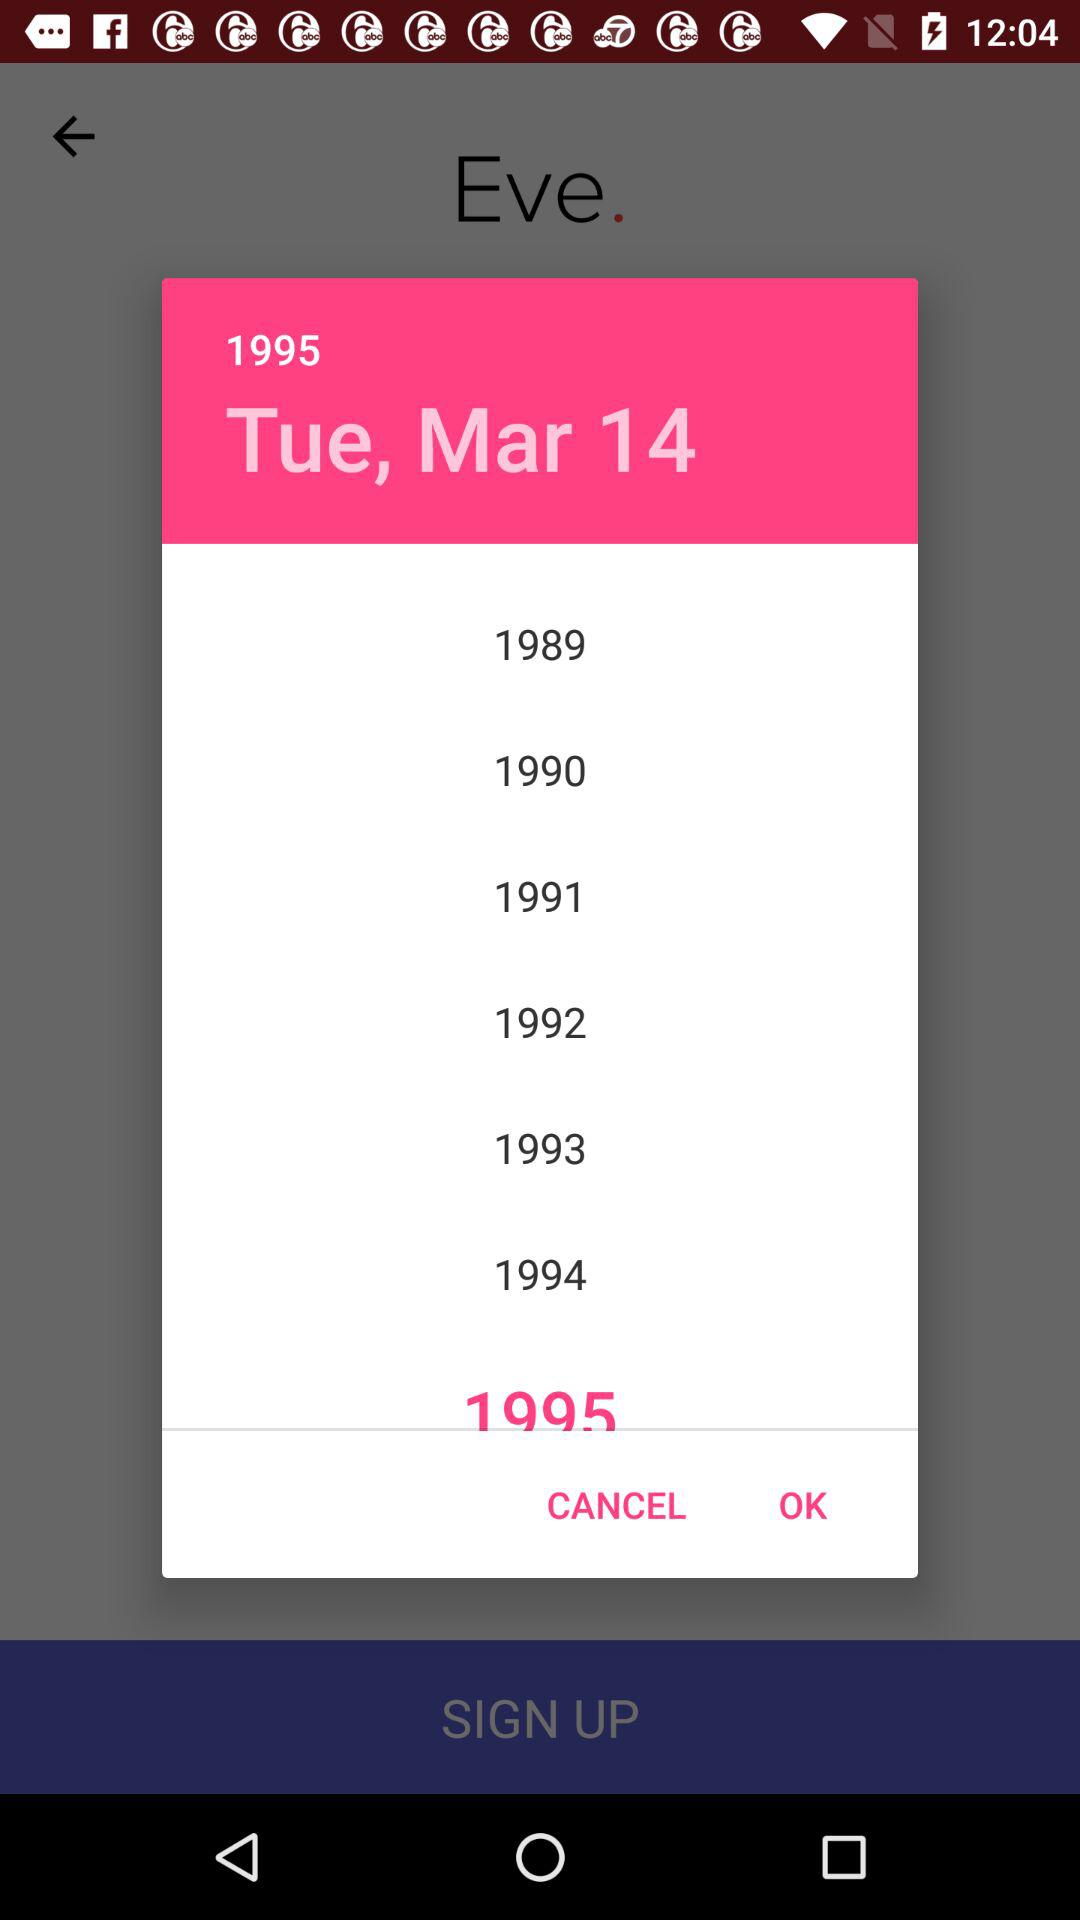What is the selected date? The selected date is Tuesday, March 14, 1995. 